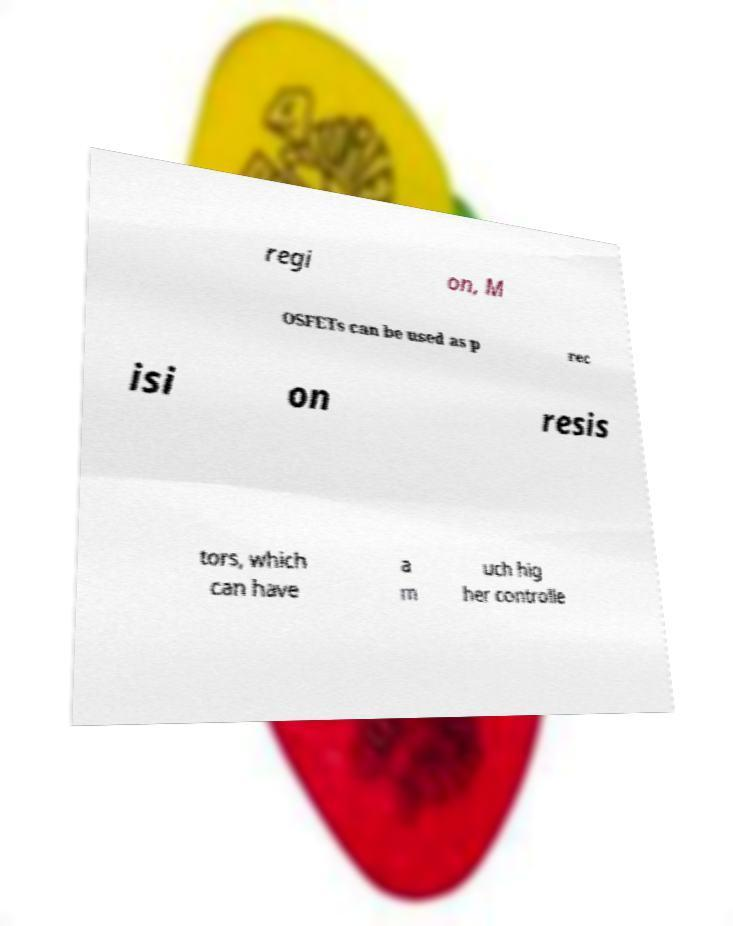Could you extract and type out the text from this image? regi on, M OSFETs can be used as p rec isi on resis tors, which can have a m uch hig her controlle 